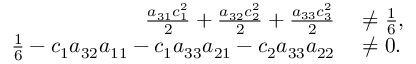Convert formula to latex. <formula><loc_0><loc_0><loc_500><loc_500>\begin{array} { r l } { \frac { a _ { 3 1 } c _ { 1 } ^ { 2 } } { 2 } + \frac { a _ { 3 2 } c _ { 2 } ^ { 2 } } { 2 } + \frac { a _ { 3 3 } c _ { 3 } ^ { 2 } } { 2 } } & \ne \frac { 1 } { 6 } , } \\ { \frac { 1 } { 6 } - c _ { 1 } a _ { 3 2 } a _ { 1 1 } - c _ { 1 } a _ { 3 3 } a _ { 2 1 } - c _ { 2 } a _ { 3 3 } a _ { 2 2 } } & \ne 0 . } \end{array}</formula> 